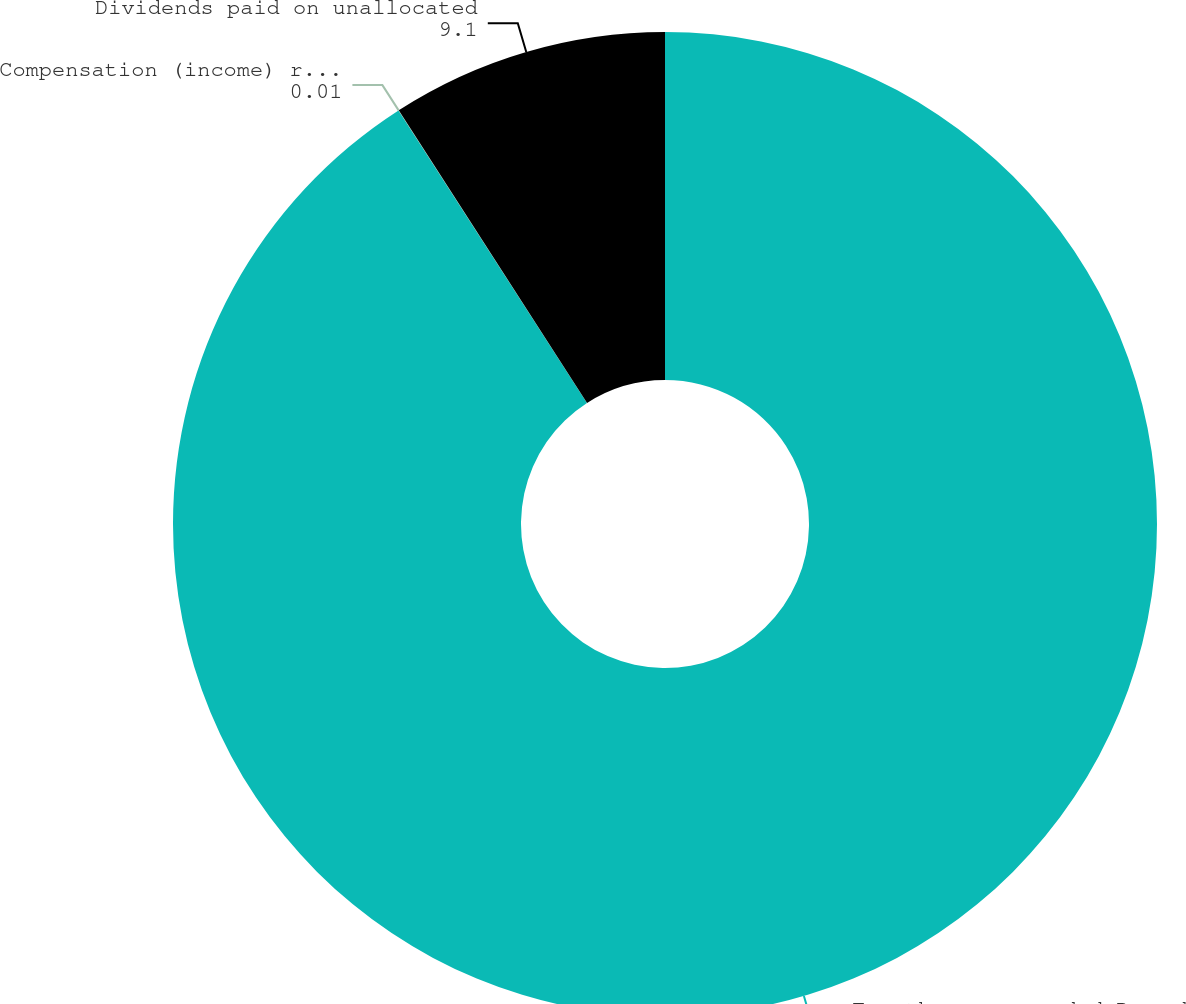Convert chart. <chart><loc_0><loc_0><loc_500><loc_500><pie_chart><fcel>For the years ended December<fcel>Compensation (income) related<fcel>Dividends paid on unallocated<nl><fcel>90.89%<fcel>0.01%<fcel>9.1%<nl></chart> 